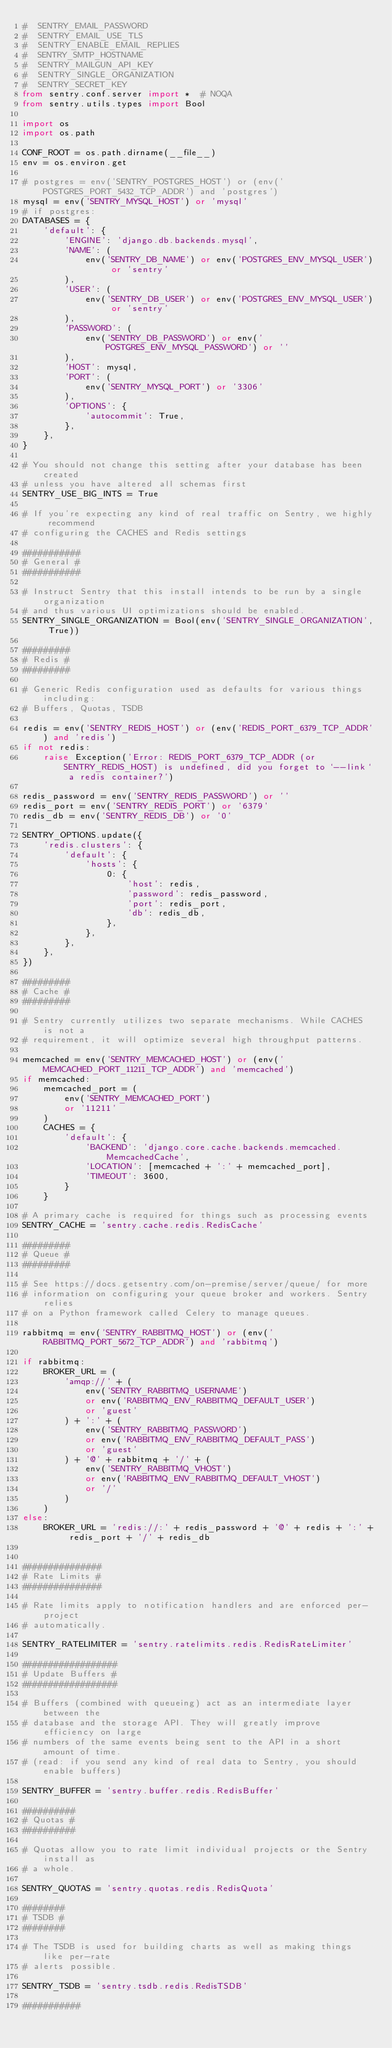Convert code to text. <code><loc_0><loc_0><loc_500><loc_500><_Python_>#  SENTRY_EMAIL_PASSWORD
#  SENTRY_EMAIL_USE_TLS
#  SENTRY_ENABLE_EMAIL_REPLIES
#  SENTRY_SMTP_HOSTNAME
#  SENTRY_MAILGUN_API_KEY
#  SENTRY_SINGLE_ORGANIZATION
#  SENTRY_SECRET_KEY
from sentry.conf.server import *  # NOQA
from sentry.utils.types import Bool

import os
import os.path

CONF_ROOT = os.path.dirname(__file__)
env = os.environ.get

# postgres = env('SENTRY_POSTGRES_HOST') or (env('POSTGRES_PORT_5432_TCP_ADDR') and 'postgres')
mysql = env('SENTRY_MYSQL_HOST') or 'mysql'
# if postgres:
DATABASES = {
    'default': {
        'ENGINE': 'django.db.backends.mysql',
        'NAME': (
            env('SENTRY_DB_NAME') or env('POSTGRES_ENV_MYSQL_USER') or 'sentry'
        ),
        'USER': (
            env('SENTRY_DB_USER') or env('POSTGRES_ENV_MYSQL_USER') or 'sentry'
        ),
        'PASSWORD': (
            env('SENTRY_DB_PASSWORD') or env('POSTGRES_ENV_MYSQL_PASSWORD') or ''
        ),
        'HOST': mysql,
        'PORT': (
            env('SENTRY_MYSQL_PORT') or '3306'
        ),
        'OPTIONS': {
            'autocommit': True,
        },
    },
}

# You should not change this setting after your database has been created
# unless you have altered all schemas first
SENTRY_USE_BIG_INTS = True

# If you're expecting any kind of real traffic on Sentry, we highly recommend
# configuring the CACHES and Redis settings

###########
# General #
###########

# Instruct Sentry that this install intends to be run by a single organization
# and thus various UI optimizations should be enabled.
SENTRY_SINGLE_ORGANIZATION = Bool(env('SENTRY_SINGLE_ORGANIZATION', True))

#########
# Redis #
#########

# Generic Redis configuration used as defaults for various things including:
# Buffers, Quotas, TSDB

redis = env('SENTRY_REDIS_HOST') or (env('REDIS_PORT_6379_TCP_ADDR') and 'redis')
if not redis:
    raise Exception('Error: REDIS_PORT_6379_TCP_ADDR (or SENTRY_REDIS_HOST) is undefined, did you forget to `--link` a redis container?')

redis_password = env('SENTRY_REDIS_PASSWORD') or ''
redis_port = env('SENTRY_REDIS_PORT') or '6379'
redis_db = env('SENTRY_REDIS_DB') or '0'

SENTRY_OPTIONS.update({
    'redis.clusters': {
        'default': {
            'hosts': {
                0: {
                    'host': redis,
                    'password': redis_password,
                    'port': redis_port,
                    'db': redis_db,
                },
            },
        },
    },
})

#########
# Cache #
#########

# Sentry currently utilizes two separate mechanisms. While CACHES is not a
# requirement, it will optimize several high throughput patterns.

memcached = env('SENTRY_MEMCACHED_HOST') or (env('MEMCACHED_PORT_11211_TCP_ADDR') and 'memcached')
if memcached:
    memcached_port = (
        env('SENTRY_MEMCACHED_PORT')
        or '11211'
    )
    CACHES = {
        'default': {
            'BACKEND': 'django.core.cache.backends.memcached.MemcachedCache',
            'LOCATION': [memcached + ':' + memcached_port],
            'TIMEOUT': 3600,
        }
    }

# A primary cache is required for things such as processing events
SENTRY_CACHE = 'sentry.cache.redis.RedisCache'

#########
# Queue #
#########

# See https://docs.getsentry.com/on-premise/server/queue/ for more
# information on configuring your queue broker and workers. Sentry relies
# on a Python framework called Celery to manage queues.

rabbitmq = env('SENTRY_RABBITMQ_HOST') or (env('RABBITMQ_PORT_5672_TCP_ADDR') and 'rabbitmq')

if rabbitmq:
    BROKER_URL = (
        'amqp://' + (
            env('SENTRY_RABBITMQ_USERNAME')
            or env('RABBITMQ_ENV_RABBITMQ_DEFAULT_USER')
            or 'guest'
        ) + ':' + (
            env('SENTRY_RABBITMQ_PASSWORD')
            or env('RABBITMQ_ENV_RABBITMQ_DEFAULT_PASS')
            or 'guest'
        ) + '@' + rabbitmq + '/' + (
            env('SENTRY_RABBITMQ_VHOST')
            or env('RABBITMQ_ENV_RABBITMQ_DEFAULT_VHOST')
            or '/'
        )
    )
else:
    BROKER_URL = 'redis://:' + redis_password + '@' + redis + ':' + redis_port + '/' + redis_db


###############
# Rate Limits #
###############

# Rate limits apply to notification handlers and are enforced per-project
# automatically.

SENTRY_RATELIMITER = 'sentry.ratelimits.redis.RedisRateLimiter'

##################
# Update Buffers #
##################

# Buffers (combined with queueing) act as an intermediate layer between the
# database and the storage API. They will greatly improve efficiency on large
# numbers of the same events being sent to the API in a short amount of time.
# (read: if you send any kind of real data to Sentry, you should enable buffers)

SENTRY_BUFFER = 'sentry.buffer.redis.RedisBuffer'

##########
# Quotas #
##########

# Quotas allow you to rate limit individual projects or the Sentry install as
# a whole.

SENTRY_QUOTAS = 'sentry.quotas.redis.RedisQuota'

########
# TSDB #
########

# The TSDB is used for building charts as well as making things like per-rate
# alerts possible.

SENTRY_TSDB = 'sentry.tsdb.redis.RedisTSDB'

###########</code> 